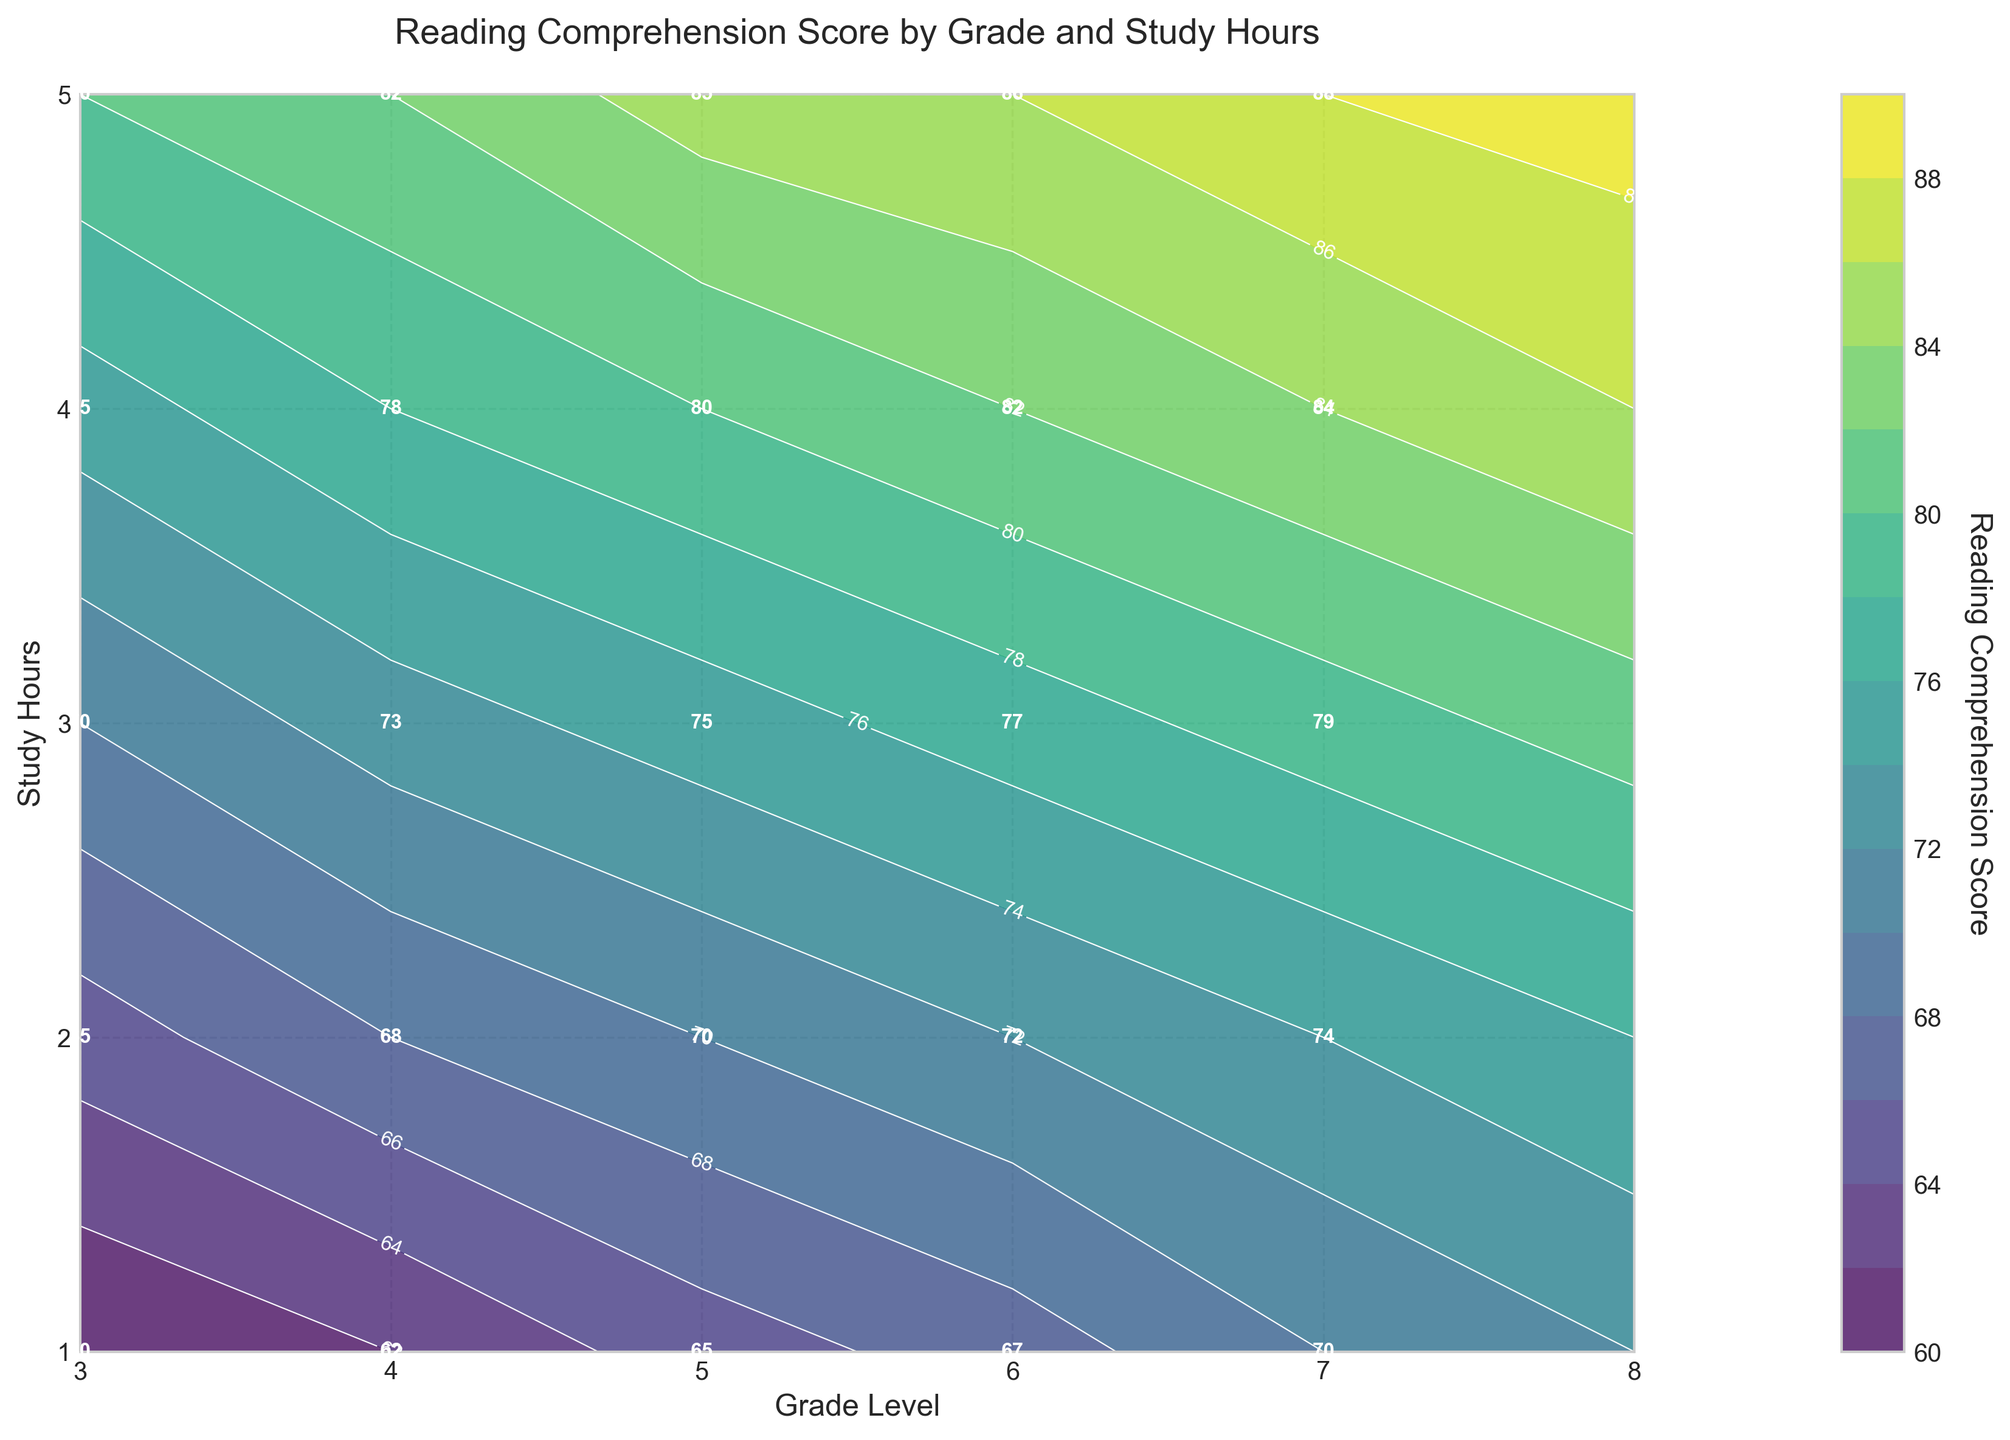what is the title of the contour plot? The title of the contour plot is prominently displayed on top of the figure.
Answer: Reading Comprehension Score by Grade and Study Hours which grade level has the highest reading comprehension score for 5 study hours? Look at the contour plot and find the maximum score in the column associated with 5 study hours.
Answer: Grade 8 what is the reading comprehension score for Grade 5 and 3 study hours? Locate the intersection of Grade 5 and 3 study hours on the contour plot to find the value labeled there.
Answer: 75 at how many study hours does a Grade 6 student reach a reading comprehension score of 82? Trace the contour lines corresponding to a score of 82 for the grade levels. Find where the line passes through Grade 6.
Answer: 4 hours compare the reading comprehension scores of Grade 4 at 2 study hours and Grade 7 at 3 study hours. Which is higher, and by how much? Find the score at the intersections for Grade 4 at 2 study hours and Grade 7 at 3 study hours. Subtract the smaller score from the larger score to determine the difference.
Answer: Grade 7 is higher by 11 (79 - 68) What trend do you observe in reading comprehension scores as grades increase for constant study hours? Inspect the scores across increasing grade levels for any fixed number of study hours from the contours. The scores tend to increase as the grade level increases.
Answer: Scores increase What is the average reading comprehension score for Grade 3 across all study hours? Refer to the scores for Grade 3 at each study hour (1 through 5). Sum these scores and divide by the number of study hours (5).
Answer: 70 Which grade and study hour combination results in the reading comprehension score of 88? Find where the contour labeled 88 intersects any grade and study hour combinations on the plot.
Answer: Grade 7 and 5 hours How much do the reading comprehension scores increase from Grade 3 to Grade 8 at 3 study hours? Find the scores for Grade 3 and Grade 8 at 3 study hours and calculate the difference between them.
Answer: Increase by 11 (81 - 70) 